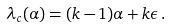<formula> <loc_0><loc_0><loc_500><loc_500>\lambda _ { c } ( \alpha ) = ( k - 1 ) \alpha + k \epsilon \, .</formula> 